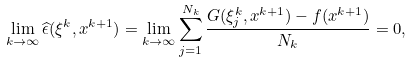<formula> <loc_0><loc_0><loc_500><loc_500>\lim _ { k \rightarrow \infty } \widehat { \epsilon } ( \xi ^ { k } , x ^ { k + 1 } ) = \lim _ { k \rightarrow \infty } \sum _ { j = 1 } ^ { N _ { k } } \frac { G ( \xi ^ { k } _ { j } , x ^ { k + 1 } ) - f ( x ^ { k + 1 } ) } { N _ { k } } = 0 ,</formula> 